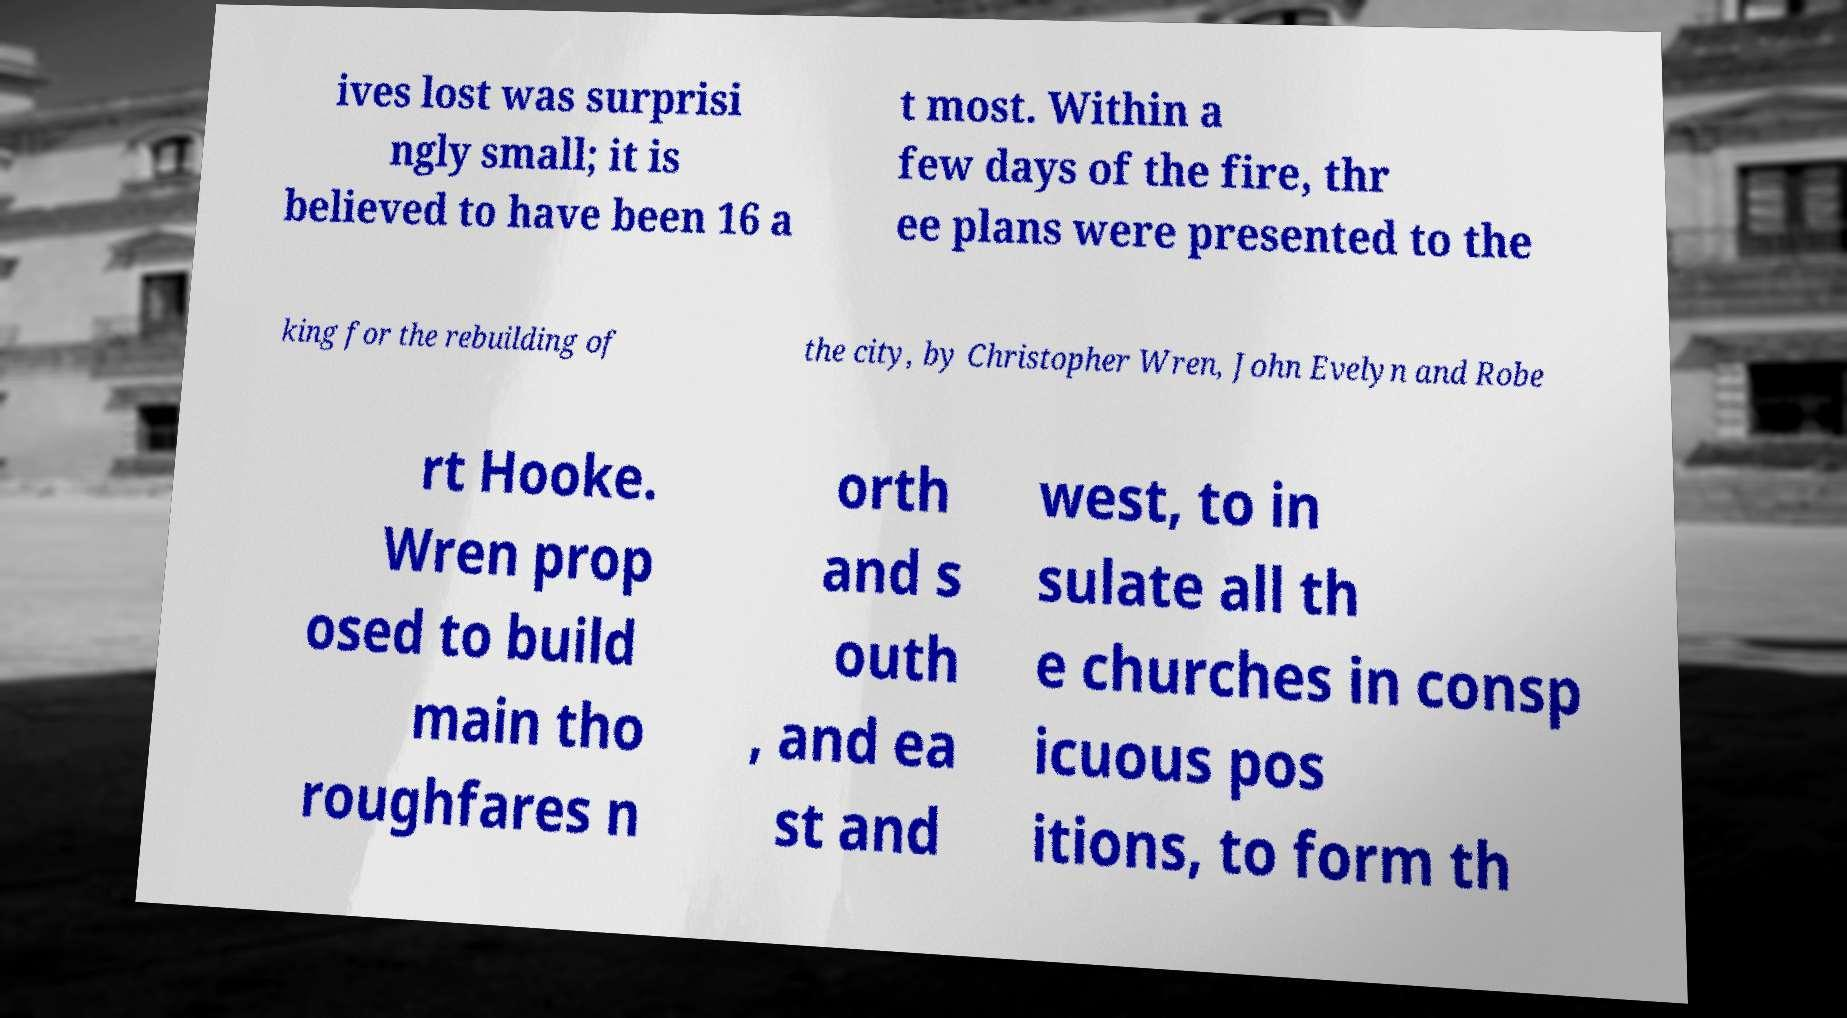What messages or text are displayed in this image? I need them in a readable, typed format. ives lost was surprisi ngly small; it is believed to have been 16 a t most. Within a few days of the fire, thr ee plans were presented to the king for the rebuilding of the city, by Christopher Wren, John Evelyn and Robe rt Hooke. Wren prop osed to build main tho roughfares n orth and s outh , and ea st and west, to in sulate all th e churches in consp icuous pos itions, to form th 